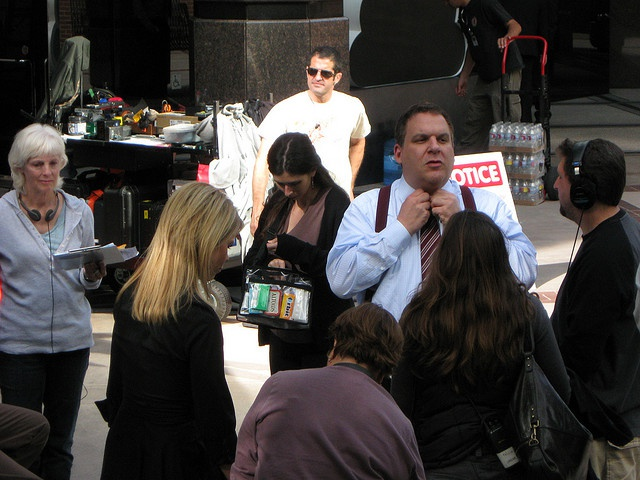Describe the objects in this image and their specific colors. I can see people in black and gray tones, people in black and gray tones, people in black, gray, and darkgray tones, people in black, gray, and maroon tones, and people in black and gray tones in this image. 